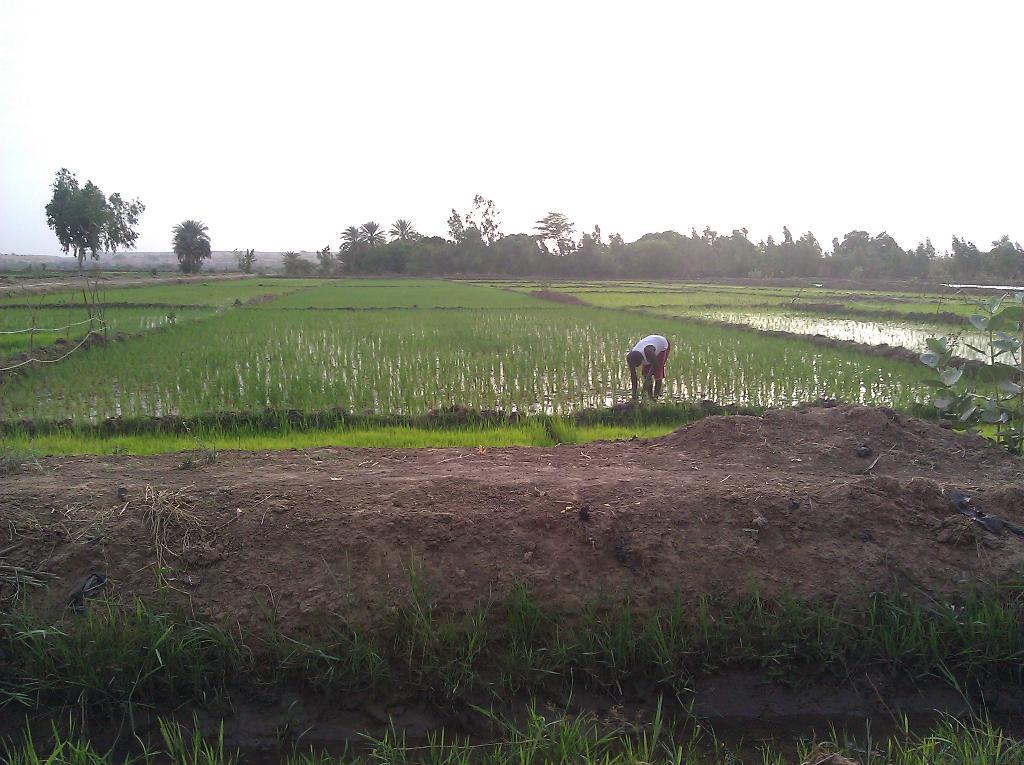Please provide a concise description of this image. In this image we can see a mud, grass, a person in the fields and in the background there are few trees and the sky. 